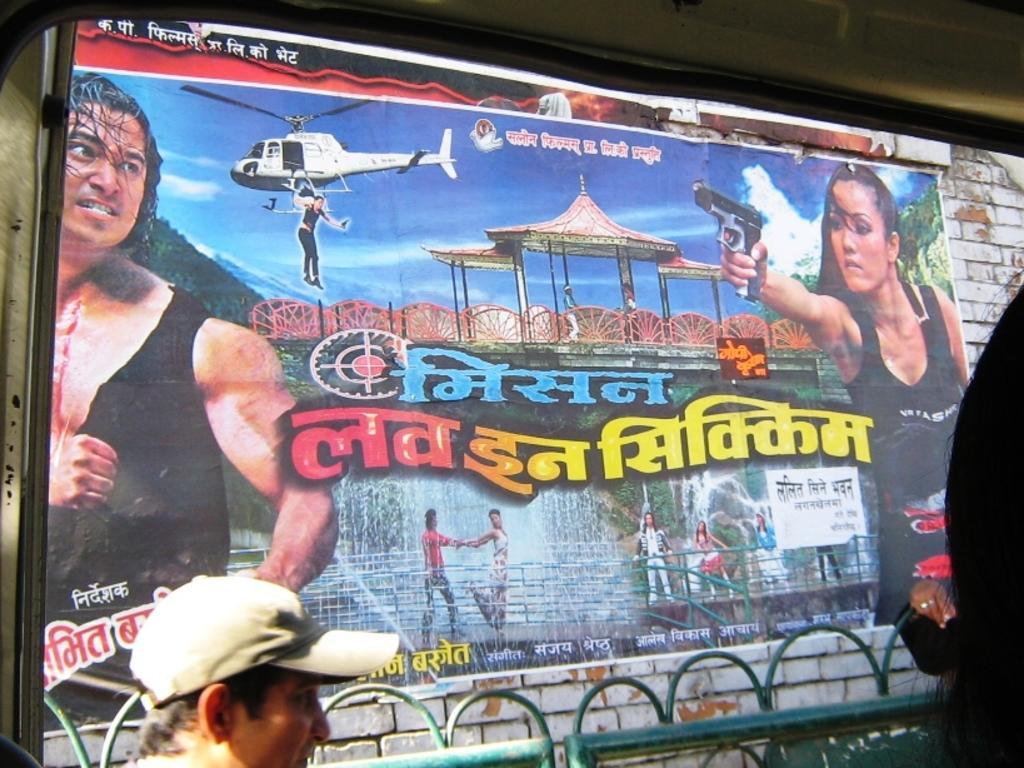Can you describe this image briefly? In this picture we can see a person and in the background we can see a poster,in this poster we can see persons,water,sky. 